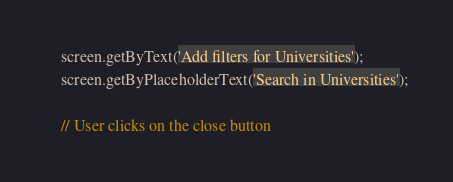<code> <loc_0><loc_0><loc_500><loc_500><_TypeScript_>
    screen.getByText('Add filters for Universities');
    screen.getByPlaceholderText('Search in Universities');

    // User clicks on the close button</code> 